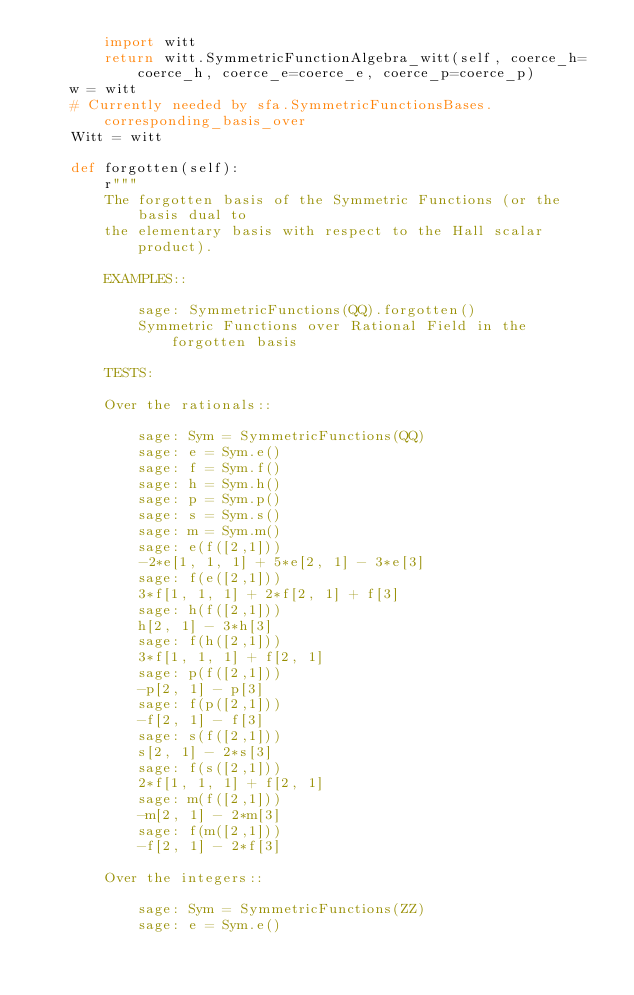Convert code to text. <code><loc_0><loc_0><loc_500><loc_500><_Python_>        import witt
        return witt.SymmetricFunctionAlgebra_witt(self, coerce_h=coerce_h, coerce_e=coerce_e, coerce_p=coerce_p)
    w = witt
    # Currently needed by sfa.SymmetricFunctionsBases.corresponding_basis_over
    Witt = witt

    def forgotten(self):
        r"""
        The forgotten basis of the Symmetric Functions (or the basis dual to
        the elementary basis with respect to the Hall scalar product).

        EXAMPLES::

            sage: SymmetricFunctions(QQ).forgotten()
            Symmetric Functions over Rational Field in the forgotten basis

        TESTS:

        Over the rationals::

            sage: Sym = SymmetricFunctions(QQ)
            sage: e = Sym.e()
            sage: f = Sym.f()
            sage: h = Sym.h()
            sage: p = Sym.p()
            sage: s = Sym.s()
            sage: m = Sym.m()
            sage: e(f([2,1]))
            -2*e[1, 1, 1] + 5*e[2, 1] - 3*e[3]
            sage: f(e([2,1]))
            3*f[1, 1, 1] + 2*f[2, 1] + f[3]
            sage: h(f([2,1]))
            h[2, 1] - 3*h[3]
            sage: f(h([2,1]))
            3*f[1, 1, 1] + f[2, 1]
            sage: p(f([2,1]))
            -p[2, 1] - p[3]
            sage: f(p([2,1]))
            -f[2, 1] - f[3]
            sage: s(f([2,1]))
            s[2, 1] - 2*s[3]
            sage: f(s([2,1]))
            2*f[1, 1, 1] + f[2, 1]
            sage: m(f([2,1]))
            -m[2, 1] - 2*m[3]
            sage: f(m([2,1]))
            -f[2, 1] - 2*f[3]

        Over the integers::

            sage: Sym = SymmetricFunctions(ZZ)
            sage: e = Sym.e()</code> 